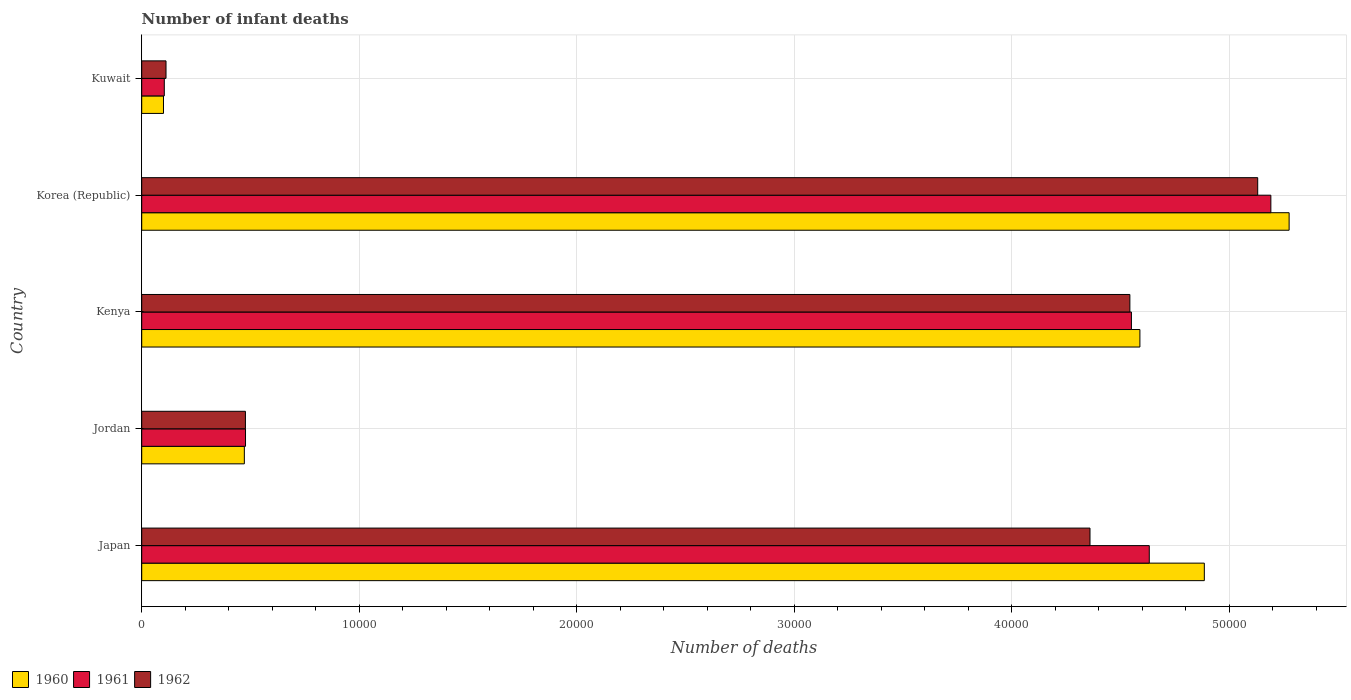How many groups of bars are there?
Your response must be concise. 5. What is the label of the 2nd group of bars from the top?
Make the answer very short. Korea (Republic). What is the number of infant deaths in 1960 in Kuwait?
Offer a terse response. 1001. Across all countries, what is the maximum number of infant deaths in 1960?
Give a very brief answer. 5.28e+04. Across all countries, what is the minimum number of infant deaths in 1962?
Your answer should be very brief. 1117. In which country was the number of infant deaths in 1962 minimum?
Ensure brevity in your answer.  Kuwait. What is the total number of infant deaths in 1962 in the graph?
Your answer should be very brief. 1.46e+05. What is the difference between the number of infant deaths in 1962 in Jordan and that in Kuwait?
Give a very brief answer. 3652. What is the difference between the number of infant deaths in 1961 in Kenya and the number of infant deaths in 1962 in Korea (Republic)?
Provide a short and direct response. -5807. What is the average number of infant deaths in 1962 per country?
Provide a short and direct response. 2.93e+04. What is the ratio of the number of infant deaths in 1961 in Jordan to that in Korea (Republic)?
Provide a short and direct response. 0.09. Is the difference between the number of infant deaths in 1961 in Japan and Korea (Republic) greater than the difference between the number of infant deaths in 1960 in Japan and Korea (Republic)?
Your answer should be compact. No. What is the difference between the highest and the second highest number of infant deaths in 1961?
Provide a short and direct response. 5591. What is the difference between the highest and the lowest number of infant deaths in 1960?
Provide a succinct answer. 5.18e+04. Is the sum of the number of infant deaths in 1961 in Korea (Republic) and Kuwait greater than the maximum number of infant deaths in 1962 across all countries?
Your answer should be very brief. Yes. What does the 3rd bar from the top in Japan represents?
Give a very brief answer. 1960. How many bars are there?
Your answer should be compact. 15. Are the values on the major ticks of X-axis written in scientific E-notation?
Offer a very short reply. No. Does the graph contain any zero values?
Provide a short and direct response. No. What is the title of the graph?
Provide a short and direct response. Number of infant deaths. Does "2002" appear as one of the legend labels in the graph?
Keep it short and to the point. No. What is the label or title of the X-axis?
Your response must be concise. Number of deaths. What is the Number of deaths in 1960 in Japan?
Your response must be concise. 4.89e+04. What is the Number of deaths in 1961 in Japan?
Offer a very short reply. 4.63e+04. What is the Number of deaths of 1962 in Japan?
Offer a very short reply. 4.36e+04. What is the Number of deaths of 1960 in Jordan?
Ensure brevity in your answer.  4719. What is the Number of deaths of 1961 in Jordan?
Give a very brief answer. 4773. What is the Number of deaths of 1962 in Jordan?
Provide a succinct answer. 4769. What is the Number of deaths of 1960 in Kenya?
Your answer should be compact. 4.59e+04. What is the Number of deaths in 1961 in Kenya?
Your answer should be compact. 4.55e+04. What is the Number of deaths in 1962 in Kenya?
Your response must be concise. 4.54e+04. What is the Number of deaths in 1960 in Korea (Republic)?
Provide a succinct answer. 5.28e+04. What is the Number of deaths in 1961 in Korea (Republic)?
Offer a very short reply. 5.19e+04. What is the Number of deaths of 1962 in Korea (Republic)?
Your answer should be very brief. 5.13e+04. What is the Number of deaths of 1960 in Kuwait?
Keep it short and to the point. 1001. What is the Number of deaths in 1961 in Kuwait?
Offer a very short reply. 1038. What is the Number of deaths in 1962 in Kuwait?
Offer a terse response. 1117. Across all countries, what is the maximum Number of deaths in 1960?
Make the answer very short. 5.28e+04. Across all countries, what is the maximum Number of deaths in 1961?
Provide a short and direct response. 5.19e+04. Across all countries, what is the maximum Number of deaths of 1962?
Provide a succinct answer. 5.13e+04. Across all countries, what is the minimum Number of deaths of 1960?
Make the answer very short. 1001. Across all countries, what is the minimum Number of deaths in 1961?
Ensure brevity in your answer.  1038. Across all countries, what is the minimum Number of deaths of 1962?
Give a very brief answer. 1117. What is the total Number of deaths of 1960 in the graph?
Your answer should be compact. 1.53e+05. What is the total Number of deaths of 1961 in the graph?
Provide a succinct answer. 1.50e+05. What is the total Number of deaths in 1962 in the graph?
Your response must be concise. 1.46e+05. What is the difference between the Number of deaths in 1960 in Japan and that in Jordan?
Provide a short and direct response. 4.41e+04. What is the difference between the Number of deaths in 1961 in Japan and that in Jordan?
Keep it short and to the point. 4.16e+04. What is the difference between the Number of deaths of 1962 in Japan and that in Jordan?
Make the answer very short. 3.88e+04. What is the difference between the Number of deaths of 1960 in Japan and that in Kenya?
Your answer should be compact. 2963. What is the difference between the Number of deaths in 1961 in Japan and that in Kenya?
Make the answer very short. 821. What is the difference between the Number of deaths in 1962 in Japan and that in Kenya?
Give a very brief answer. -1834. What is the difference between the Number of deaths in 1960 in Japan and that in Korea (Republic)?
Provide a succinct answer. -3899. What is the difference between the Number of deaths of 1961 in Japan and that in Korea (Republic)?
Provide a short and direct response. -5591. What is the difference between the Number of deaths in 1962 in Japan and that in Korea (Republic)?
Offer a terse response. -7712. What is the difference between the Number of deaths of 1960 in Japan and that in Kuwait?
Ensure brevity in your answer.  4.79e+04. What is the difference between the Number of deaths of 1961 in Japan and that in Kuwait?
Make the answer very short. 4.53e+04. What is the difference between the Number of deaths in 1962 in Japan and that in Kuwait?
Your response must be concise. 4.25e+04. What is the difference between the Number of deaths in 1960 in Jordan and that in Kenya?
Your response must be concise. -4.12e+04. What is the difference between the Number of deaths in 1961 in Jordan and that in Kenya?
Provide a succinct answer. -4.07e+04. What is the difference between the Number of deaths of 1962 in Jordan and that in Kenya?
Your answer should be very brief. -4.07e+04. What is the difference between the Number of deaths of 1960 in Jordan and that in Korea (Republic)?
Your answer should be compact. -4.80e+04. What is the difference between the Number of deaths in 1961 in Jordan and that in Korea (Republic)?
Provide a succinct answer. -4.72e+04. What is the difference between the Number of deaths of 1962 in Jordan and that in Korea (Republic)?
Ensure brevity in your answer.  -4.66e+04. What is the difference between the Number of deaths in 1960 in Jordan and that in Kuwait?
Your answer should be very brief. 3718. What is the difference between the Number of deaths in 1961 in Jordan and that in Kuwait?
Make the answer very short. 3735. What is the difference between the Number of deaths in 1962 in Jordan and that in Kuwait?
Your answer should be very brief. 3652. What is the difference between the Number of deaths in 1960 in Kenya and that in Korea (Republic)?
Provide a succinct answer. -6862. What is the difference between the Number of deaths of 1961 in Kenya and that in Korea (Republic)?
Provide a short and direct response. -6412. What is the difference between the Number of deaths of 1962 in Kenya and that in Korea (Republic)?
Ensure brevity in your answer.  -5878. What is the difference between the Number of deaths in 1960 in Kenya and that in Kuwait?
Make the answer very short. 4.49e+04. What is the difference between the Number of deaths of 1961 in Kenya and that in Kuwait?
Keep it short and to the point. 4.45e+04. What is the difference between the Number of deaths of 1962 in Kenya and that in Kuwait?
Ensure brevity in your answer.  4.43e+04. What is the difference between the Number of deaths in 1960 in Korea (Republic) and that in Kuwait?
Offer a very short reply. 5.18e+04. What is the difference between the Number of deaths of 1961 in Korea (Republic) and that in Kuwait?
Offer a very short reply. 5.09e+04. What is the difference between the Number of deaths in 1962 in Korea (Republic) and that in Kuwait?
Offer a terse response. 5.02e+04. What is the difference between the Number of deaths in 1960 in Japan and the Number of deaths in 1961 in Jordan?
Offer a very short reply. 4.41e+04. What is the difference between the Number of deaths of 1960 in Japan and the Number of deaths of 1962 in Jordan?
Make the answer very short. 4.41e+04. What is the difference between the Number of deaths of 1961 in Japan and the Number of deaths of 1962 in Jordan?
Ensure brevity in your answer.  4.16e+04. What is the difference between the Number of deaths of 1960 in Japan and the Number of deaths of 1961 in Kenya?
Make the answer very short. 3353. What is the difference between the Number of deaths in 1960 in Japan and the Number of deaths in 1962 in Kenya?
Your response must be concise. 3424. What is the difference between the Number of deaths in 1961 in Japan and the Number of deaths in 1962 in Kenya?
Your response must be concise. 892. What is the difference between the Number of deaths of 1960 in Japan and the Number of deaths of 1961 in Korea (Republic)?
Give a very brief answer. -3059. What is the difference between the Number of deaths of 1960 in Japan and the Number of deaths of 1962 in Korea (Republic)?
Ensure brevity in your answer.  -2454. What is the difference between the Number of deaths of 1961 in Japan and the Number of deaths of 1962 in Korea (Republic)?
Your answer should be very brief. -4986. What is the difference between the Number of deaths in 1960 in Japan and the Number of deaths in 1961 in Kuwait?
Provide a succinct answer. 4.78e+04. What is the difference between the Number of deaths of 1960 in Japan and the Number of deaths of 1962 in Kuwait?
Your response must be concise. 4.77e+04. What is the difference between the Number of deaths in 1961 in Japan and the Number of deaths in 1962 in Kuwait?
Your answer should be very brief. 4.52e+04. What is the difference between the Number of deaths in 1960 in Jordan and the Number of deaths in 1961 in Kenya?
Your response must be concise. -4.08e+04. What is the difference between the Number of deaths in 1960 in Jordan and the Number of deaths in 1962 in Kenya?
Your response must be concise. -4.07e+04. What is the difference between the Number of deaths in 1961 in Jordan and the Number of deaths in 1962 in Kenya?
Give a very brief answer. -4.07e+04. What is the difference between the Number of deaths of 1960 in Jordan and the Number of deaths of 1961 in Korea (Republic)?
Provide a succinct answer. -4.72e+04. What is the difference between the Number of deaths of 1960 in Jordan and the Number of deaths of 1962 in Korea (Republic)?
Your answer should be very brief. -4.66e+04. What is the difference between the Number of deaths of 1961 in Jordan and the Number of deaths of 1962 in Korea (Republic)?
Offer a very short reply. -4.65e+04. What is the difference between the Number of deaths of 1960 in Jordan and the Number of deaths of 1961 in Kuwait?
Your answer should be very brief. 3681. What is the difference between the Number of deaths of 1960 in Jordan and the Number of deaths of 1962 in Kuwait?
Provide a short and direct response. 3602. What is the difference between the Number of deaths of 1961 in Jordan and the Number of deaths of 1962 in Kuwait?
Your answer should be very brief. 3656. What is the difference between the Number of deaths of 1960 in Kenya and the Number of deaths of 1961 in Korea (Republic)?
Provide a succinct answer. -6022. What is the difference between the Number of deaths of 1960 in Kenya and the Number of deaths of 1962 in Korea (Republic)?
Offer a terse response. -5417. What is the difference between the Number of deaths of 1961 in Kenya and the Number of deaths of 1962 in Korea (Republic)?
Your response must be concise. -5807. What is the difference between the Number of deaths in 1960 in Kenya and the Number of deaths in 1961 in Kuwait?
Provide a succinct answer. 4.49e+04. What is the difference between the Number of deaths in 1960 in Kenya and the Number of deaths in 1962 in Kuwait?
Provide a succinct answer. 4.48e+04. What is the difference between the Number of deaths of 1961 in Kenya and the Number of deaths of 1962 in Kuwait?
Offer a terse response. 4.44e+04. What is the difference between the Number of deaths of 1960 in Korea (Republic) and the Number of deaths of 1961 in Kuwait?
Give a very brief answer. 5.17e+04. What is the difference between the Number of deaths of 1960 in Korea (Republic) and the Number of deaths of 1962 in Kuwait?
Offer a very short reply. 5.16e+04. What is the difference between the Number of deaths in 1961 in Korea (Republic) and the Number of deaths in 1962 in Kuwait?
Offer a very short reply. 5.08e+04. What is the average Number of deaths in 1960 per country?
Ensure brevity in your answer.  3.07e+04. What is the average Number of deaths in 1961 per country?
Provide a short and direct response. 2.99e+04. What is the average Number of deaths of 1962 per country?
Your answer should be very brief. 2.93e+04. What is the difference between the Number of deaths in 1960 and Number of deaths in 1961 in Japan?
Your response must be concise. 2532. What is the difference between the Number of deaths in 1960 and Number of deaths in 1962 in Japan?
Keep it short and to the point. 5258. What is the difference between the Number of deaths in 1961 and Number of deaths in 1962 in Japan?
Make the answer very short. 2726. What is the difference between the Number of deaths in 1960 and Number of deaths in 1961 in Jordan?
Make the answer very short. -54. What is the difference between the Number of deaths of 1960 and Number of deaths of 1962 in Jordan?
Offer a very short reply. -50. What is the difference between the Number of deaths in 1960 and Number of deaths in 1961 in Kenya?
Provide a succinct answer. 390. What is the difference between the Number of deaths of 1960 and Number of deaths of 1962 in Kenya?
Make the answer very short. 461. What is the difference between the Number of deaths of 1961 and Number of deaths of 1962 in Kenya?
Ensure brevity in your answer.  71. What is the difference between the Number of deaths of 1960 and Number of deaths of 1961 in Korea (Republic)?
Offer a very short reply. 840. What is the difference between the Number of deaths in 1960 and Number of deaths in 1962 in Korea (Republic)?
Offer a very short reply. 1445. What is the difference between the Number of deaths of 1961 and Number of deaths of 1962 in Korea (Republic)?
Keep it short and to the point. 605. What is the difference between the Number of deaths of 1960 and Number of deaths of 1961 in Kuwait?
Your response must be concise. -37. What is the difference between the Number of deaths in 1960 and Number of deaths in 1962 in Kuwait?
Provide a succinct answer. -116. What is the difference between the Number of deaths of 1961 and Number of deaths of 1962 in Kuwait?
Make the answer very short. -79. What is the ratio of the Number of deaths in 1960 in Japan to that in Jordan?
Keep it short and to the point. 10.35. What is the ratio of the Number of deaths of 1961 in Japan to that in Jordan?
Make the answer very short. 9.71. What is the ratio of the Number of deaths in 1962 in Japan to that in Jordan?
Keep it short and to the point. 9.14. What is the ratio of the Number of deaths of 1960 in Japan to that in Kenya?
Your answer should be very brief. 1.06. What is the ratio of the Number of deaths of 1961 in Japan to that in Kenya?
Provide a succinct answer. 1.02. What is the ratio of the Number of deaths in 1962 in Japan to that in Kenya?
Give a very brief answer. 0.96. What is the ratio of the Number of deaths in 1960 in Japan to that in Korea (Republic)?
Give a very brief answer. 0.93. What is the ratio of the Number of deaths of 1961 in Japan to that in Korea (Republic)?
Provide a succinct answer. 0.89. What is the ratio of the Number of deaths of 1962 in Japan to that in Korea (Republic)?
Offer a terse response. 0.85. What is the ratio of the Number of deaths of 1960 in Japan to that in Kuwait?
Ensure brevity in your answer.  48.82. What is the ratio of the Number of deaths of 1961 in Japan to that in Kuwait?
Keep it short and to the point. 44.64. What is the ratio of the Number of deaths in 1962 in Japan to that in Kuwait?
Ensure brevity in your answer.  39.04. What is the ratio of the Number of deaths in 1960 in Jordan to that in Kenya?
Offer a terse response. 0.1. What is the ratio of the Number of deaths in 1961 in Jordan to that in Kenya?
Your response must be concise. 0.1. What is the ratio of the Number of deaths of 1962 in Jordan to that in Kenya?
Offer a terse response. 0.1. What is the ratio of the Number of deaths of 1960 in Jordan to that in Korea (Republic)?
Offer a terse response. 0.09. What is the ratio of the Number of deaths of 1961 in Jordan to that in Korea (Republic)?
Ensure brevity in your answer.  0.09. What is the ratio of the Number of deaths of 1962 in Jordan to that in Korea (Republic)?
Offer a very short reply. 0.09. What is the ratio of the Number of deaths of 1960 in Jordan to that in Kuwait?
Give a very brief answer. 4.71. What is the ratio of the Number of deaths of 1961 in Jordan to that in Kuwait?
Keep it short and to the point. 4.6. What is the ratio of the Number of deaths in 1962 in Jordan to that in Kuwait?
Your answer should be very brief. 4.27. What is the ratio of the Number of deaths in 1960 in Kenya to that in Korea (Republic)?
Your answer should be very brief. 0.87. What is the ratio of the Number of deaths of 1961 in Kenya to that in Korea (Republic)?
Offer a very short reply. 0.88. What is the ratio of the Number of deaths of 1962 in Kenya to that in Korea (Republic)?
Offer a terse response. 0.89. What is the ratio of the Number of deaths of 1960 in Kenya to that in Kuwait?
Keep it short and to the point. 45.86. What is the ratio of the Number of deaths of 1961 in Kenya to that in Kuwait?
Give a very brief answer. 43.85. What is the ratio of the Number of deaths of 1962 in Kenya to that in Kuwait?
Give a very brief answer. 40.68. What is the ratio of the Number of deaths of 1960 in Korea (Republic) to that in Kuwait?
Keep it short and to the point. 52.71. What is the ratio of the Number of deaths in 1961 in Korea (Republic) to that in Kuwait?
Offer a very short reply. 50.02. What is the ratio of the Number of deaths of 1962 in Korea (Republic) to that in Kuwait?
Offer a very short reply. 45.94. What is the difference between the highest and the second highest Number of deaths in 1960?
Provide a succinct answer. 3899. What is the difference between the highest and the second highest Number of deaths of 1961?
Give a very brief answer. 5591. What is the difference between the highest and the second highest Number of deaths in 1962?
Offer a very short reply. 5878. What is the difference between the highest and the lowest Number of deaths of 1960?
Your response must be concise. 5.18e+04. What is the difference between the highest and the lowest Number of deaths of 1961?
Make the answer very short. 5.09e+04. What is the difference between the highest and the lowest Number of deaths in 1962?
Keep it short and to the point. 5.02e+04. 